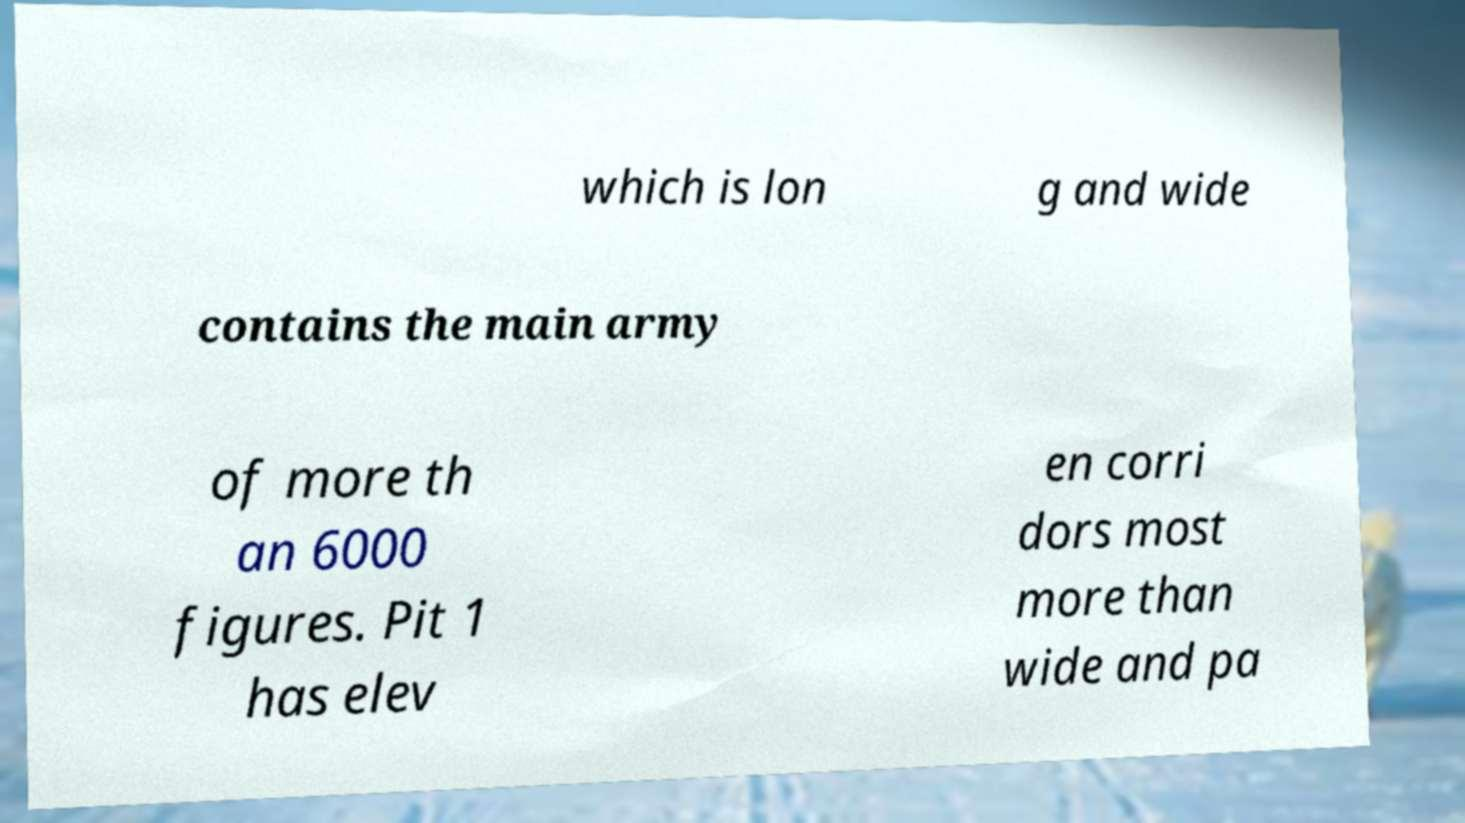For documentation purposes, I need the text within this image transcribed. Could you provide that? which is lon g and wide contains the main army of more th an 6000 figures. Pit 1 has elev en corri dors most more than wide and pa 